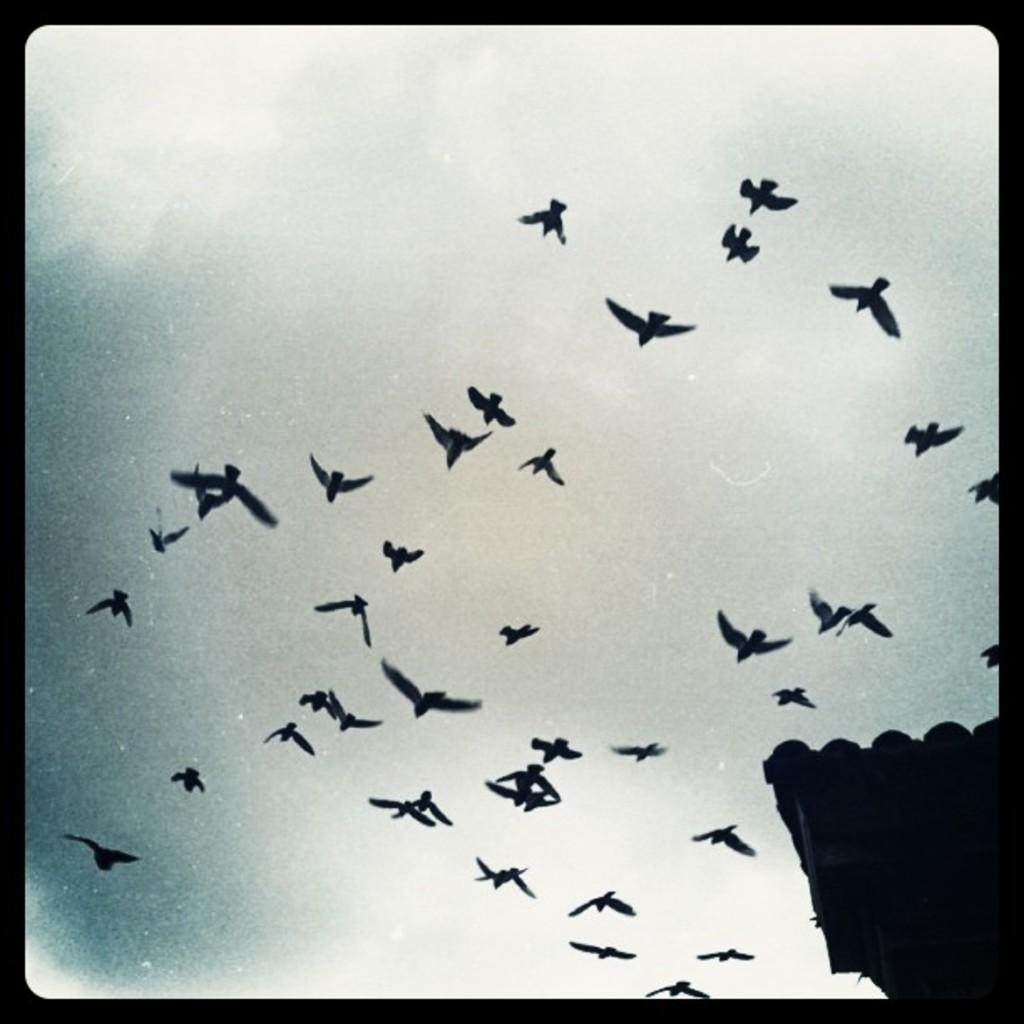What is the color scheme of the image? The image is black and white. What can be seen in the sky in the image? There are birds flying in the sky in the image. What type of payment is required to enter the building in the image? There is no building or payment mentioned in the image; it only features birds flying in the sky. 